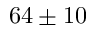Convert formula to latex. <formula><loc_0><loc_0><loc_500><loc_500>6 4 \pm 1 0</formula> 